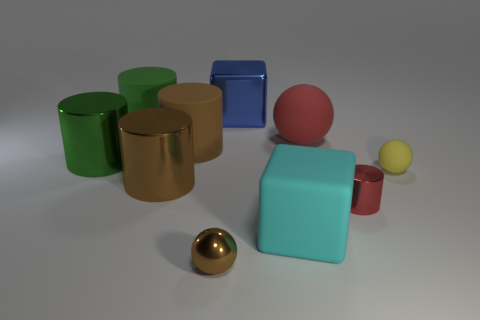There is a small yellow sphere; how many brown metallic balls are behind it?
Give a very brief answer. 0. Are any big red rubber balls visible?
Your answer should be compact. Yes. There is a ball that is in front of the red object in front of the brown metal thing that is behind the tiny brown metallic ball; what color is it?
Ensure brevity in your answer.  Brown. There is a brown shiny thing behind the brown sphere; are there any small red cylinders left of it?
Your answer should be compact. No. Do the rubber ball that is behind the green shiny cylinder and the metallic thing right of the blue object have the same color?
Make the answer very short. Yes. What number of brown cylinders have the same size as the matte block?
Provide a succinct answer. 2. There is a brown cylinder that is behind the yellow rubber sphere; is its size the same as the red sphere?
Your answer should be very brief. Yes. What is the shape of the red metallic thing?
Your response must be concise. Cylinder. There is a matte object that is the same color as the tiny shiny cylinder; what size is it?
Your answer should be compact. Large. Does the large block that is behind the large rubber cube have the same material as the tiny red object?
Offer a terse response. Yes. 